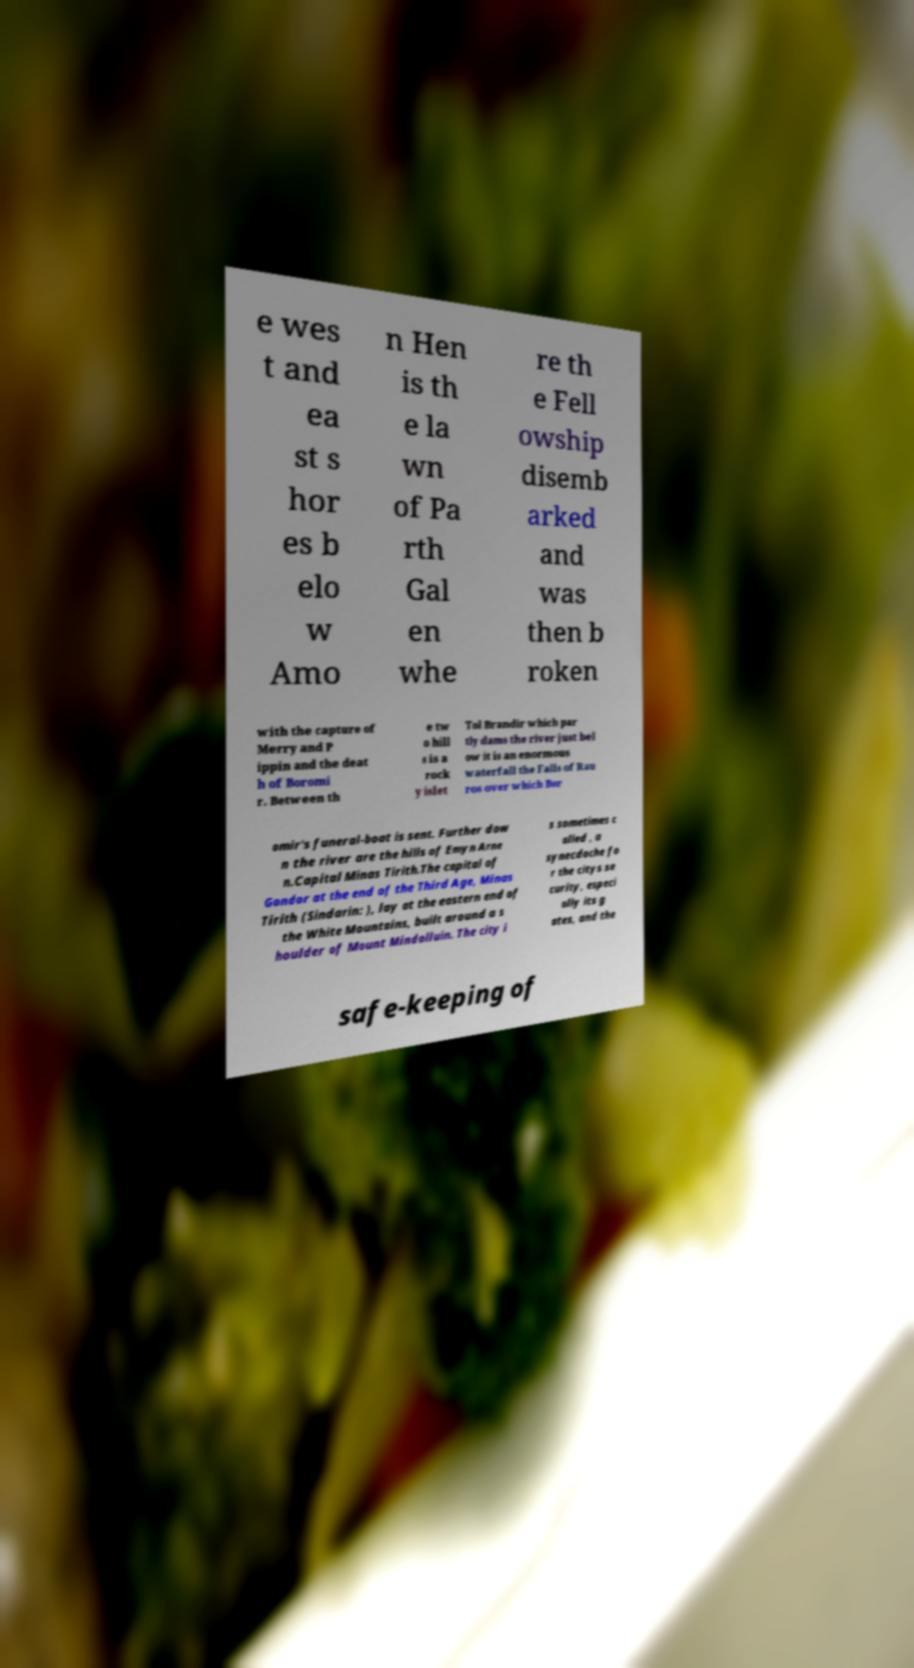What messages or text are displayed in this image? I need them in a readable, typed format. e wes t and ea st s hor es b elo w Amo n Hen is th e la wn of Pa rth Gal en whe re th e Fell owship disemb arked and was then b roken with the capture of Merry and P ippin and the deat h of Boromi r. Between th e tw o hill s is a rock y islet Tol Brandir which par tly dams the river just bel ow it is an enormous waterfall the Falls of Rau ros over which Bor omir's funeral-boat is sent. Further dow n the river are the hills of Emyn Arne n.Capital Minas Tirith.The capital of Gondor at the end of the Third Age, Minas Tirith (Sindarin: ), lay at the eastern end of the White Mountains, built around a s houlder of Mount Mindolluin. The city i s sometimes c alled , a synecdoche fo r the citys se curity, especi ally its g ates, and the safe-keeping of 